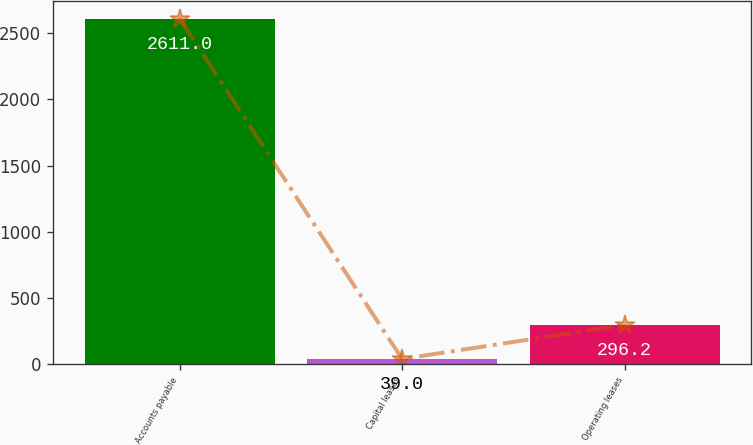Convert chart. <chart><loc_0><loc_0><loc_500><loc_500><bar_chart><fcel>Accounts payable<fcel>Capital leases<fcel>Operating leases<nl><fcel>2611<fcel>39<fcel>296.2<nl></chart> 